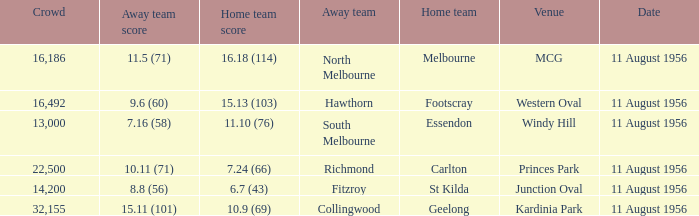18 (114)? Melbourne. 